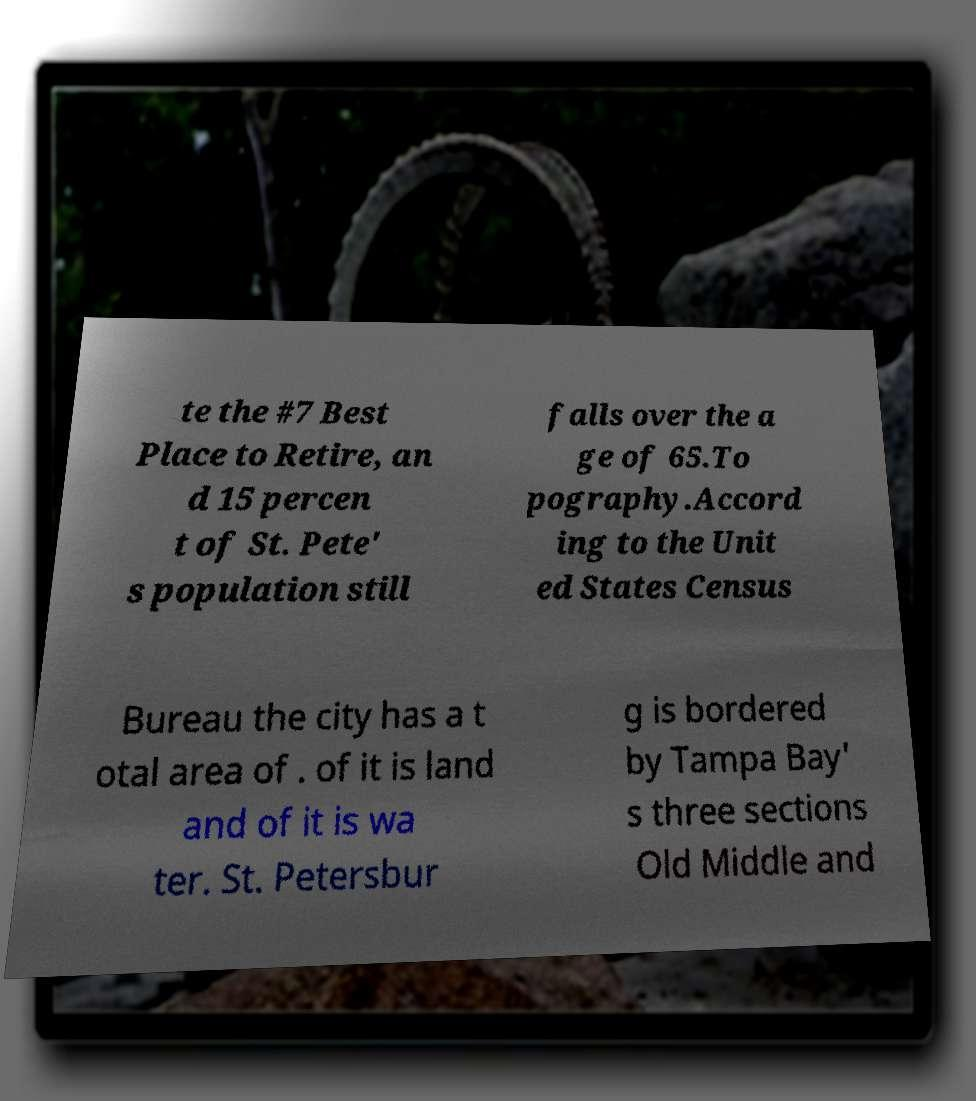I need the written content from this picture converted into text. Can you do that? te the #7 Best Place to Retire, an d 15 percen t of St. Pete' s population still falls over the a ge of 65.To pography.Accord ing to the Unit ed States Census Bureau the city has a t otal area of . of it is land and of it is wa ter. St. Petersbur g is bordered by Tampa Bay' s three sections Old Middle and 